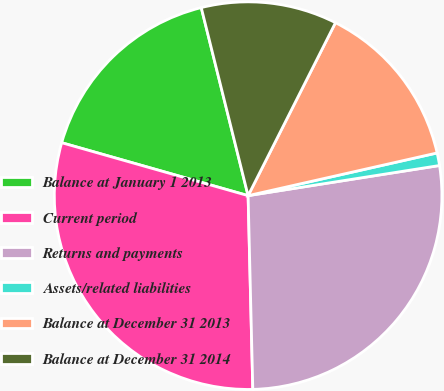Convert chart to OTSL. <chart><loc_0><loc_0><loc_500><loc_500><pie_chart><fcel>Balance at January 1 2013<fcel>Current period<fcel>Returns and payments<fcel>Assets/related liabilities<fcel>Balance at December 31 2013<fcel>Balance at December 31 2014<nl><fcel>16.71%<fcel>29.79%<fcel>27.1%<fcel>1.05%<fcel>14.02%<fcel>11.33%<nl></chart> 